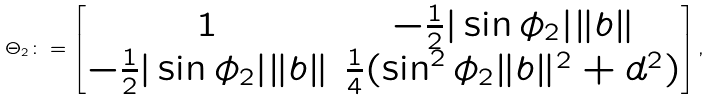<formula> <loc_0><loc_0><loc_500><loc_500>\Theta _ { 2 } \colon = \begin{bmatrix} 1 & - \frac { 1 } { 2 } | \sin \phi _ { 2 } | \| b \| \\ - \frac { 1 } { 2 } | \sin \phi _ { 2 } | \| b \| & \frac { 1 } { 4 } ( \sin ^ { 2 } \phi _ { 2 } \| b \| ^ { 2 } + d ^ { 2 } ) \end{bmatrix} ,</formula> 